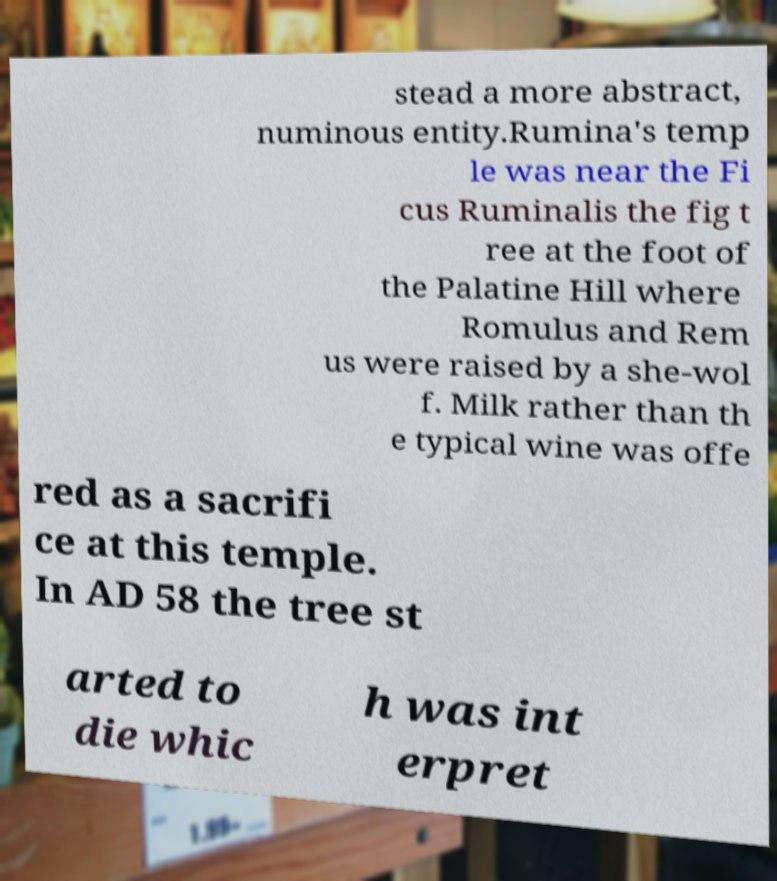Please read and relay the text visible in this image. What does it say? stead a more abstract, numinous entity.Rumina's temp le was near the Fi cus Ruminalis the fig t ree at the foot of the Palatine Hill where Romulus and Rem us were raised by a she-wol f. Milk rather than th e typical wine was offe red as a sacrifi ce at this temple. In AD 58 the tree st arted to die whic h was int erpret 